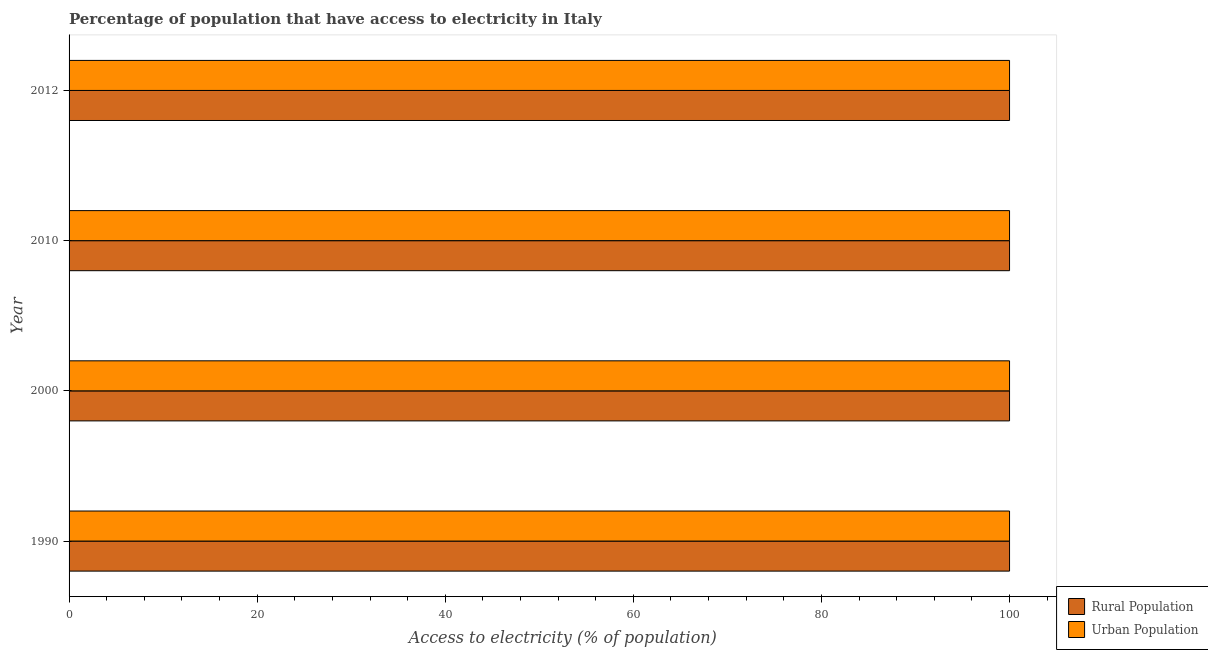How many different coloured bars are there?
Give a very brief answer. 2. How many groups of bars are there?
Offer a terse response. 4. Are the number of bars per tick equal to the number of legend labels?
Offer a terse response. Yes. What is the label of the 1st group of bars from the top?
Offer a terse response. 2012. In how many cases, is the number of bars for a given year not equal to the number of legend labels?
Your response must be concise. 0. What is the percentage of rural population having access to electricity in 2010?
Keep it short and to the point. 100. Across all years, what is the maximum percentage of rural population having access to electricity?
Offer a terse response. 100. Across all years, what is the minimum percentage of urban population having access to electricity?
Offer a very short reply. 100. In which year was the percentage of urban population having access to electricity maximum?
Make the answer very short. 1990. In which year was the percentage of urban population having access to electricity minimum?
Keep it short and to the point. 1990. What is the total percentage of urban population having access to electricity in the graph?
Offer a terse response. 400. What is the difference between the percentage of rural population having access to electricity in 2012 and the percentage of urban population having access to electricity in 2010?
Your answer should be very brief. 0. In the year 2000, what is the difference between the percentage of rural population having access to electricity and percentage of urban population having access to electricity?
Provide a short and direct response. 0. What is the ratio of the percentage of urban population having access to electricity in 1990 to that in 2010?
Your answer should be compact. 1. What is the difference between the highest and the lowest percentage of urban population having access to electricity?
Make the answer very short. 0. What does the 2nd bar from the top in 2012 represents?
Offer a terse response. Rural Population. What does the 2nd bar from the bottom in 1990 represents?
Ensure brevity in your answer.  Urban Population. Are the values on the major ticks of X-axis written in scientific E-notation?
Make the answer very short. No. Does the graph contain grids?
Your answer should be very brief. No. Where does the legend appear in the graph?
Your answer should be very brief. Bottom right. What is the title of the graph?
Provide a succinct answer. Percentage of population that have access to electricity in Italy. Does "National Tourists" appear as one of the legend labels in the graph?
Keep it short and to the point. No. What is the label or title of the X-axis?
Your answer should be compact. Access to electricity (% of population). What is the label or title of the Y-axis?
Your answer should be very brief. Year. What is the Access to electricity (% of population) in Rural Population in 1990?
Ensure brevity in your answer.  100. What is the Access to electricity (% of population) in Urban Population in 2000?
Your answer should be very brief. 100. What is the Access to electricity (% of population) in Urban Population in 2010?
Provide a succinct answer. 100. What is the Access to electricity (% of population) in Rural Population in 2012?
Make the answer very short. 100. Across all years, what is the minimum Access to electricity (% of population) in Urban Population?
Keep it short and to the point. 100. What is the total Access to electricity (% of population) of Rural Population in the graph?
Your answer should be very brief. 400. What is the difference between the Access to electricity (% of population) of Rural Population in 1990 and that in 2000?
Your answer should be compact. 0. What is the difference between the Access to electricity (% of population) in Urban Population in 1990 and that in 2012?
Provide a short and direct response. 0. What is the difference between the Access to electricity (% of population) of Rural Population in 2010 and that in 2012?
Give a very brief answer. 0. What is the difference between the Access to electricity (% of population) in Rural Population in 1990 and the Access to electricity (% of population) in Urban Population in 2000?
Make the answer very short. 0. What is the difference between the Access to electricity (% of population) of Rural Population in 1990 and the Access to electricity (% of population) of Urban Population in 2010?
Offer a terse response. 0. What is the difference between the Access to electricity (% of population) of Rural Population in 1990 and the Access to electricity (% of population) of Urban Population in 2012?
Your response must be concise. 0. What is the average Access to electricity (% of population) of Rural Population per year?
Provide a succinct answer. 100. What is the average Access to electricity (% of population) in Urban Population per year?
Offer a terse response. 100. In the year 2000, what is the difference between the Access to electricity (% of population) in Rural Population and Access to electricity (% of population) in Urban Population?
Make the answer very short. 0. In the year 2010, what is the difference between the Access to electricity (% of population) of Rural Population and Access to electricity (% of population) of Urban Population?
Keep it short and to the point. 0. In the year 2012, what is the difference between the Access to electricity (% of population) of Rural Population and Access to electricity (% of population) of Urban Population?
Make the answer very short. 0. What is the ratio of the Access to electricity (% of population) of Rural Population in 1990 to that in 2000?
Your answer should be very brief. 1. What is the ratio of the Access to electricity (% of population) of Urban Population in 1990 to that in 2010?
Your response must be concise. 1. What is the ratio of the Access to electricity (% of population) of Rural Population in 1990 to that in 2012?
Keep it short and to the point. 1. What is the ratio of the Access to electricity (% of population) in Urban Population in 1990 to that in 2012?
Provide a succinct answer. 1. What is the ratio of the Access to electricity (% of population) in Rural Population in 2000 to that in 2010?
Your response must be concise. 1. What is the ratio of the Access to electricity (% of population) of Rural Population in 2000 to that in 2012?
Provide a succinct answer. 1. What is the ratio of the Access to electricity (% of population) of Urban Population in 2010 to that in 2012?
Ensure brevity in your answer.  1. What is the difference between the highest and the second highest Access to electricity (% of population) in Rural Population?
Give a very brief answer. 0. What is the difference between the highest and the lowest Access to electricity (% of population) in Urban Population?
Provide a succinct answer. 0. 